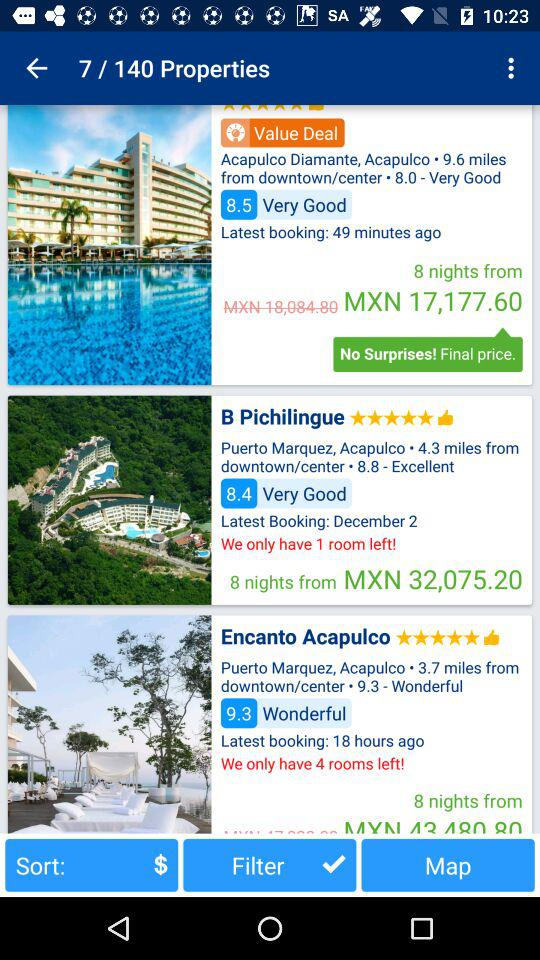How do people like Encanto Acapulco?
When the provided information is insufficient, respond with <no answer>. <no answer> 